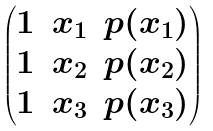Convert formula to latex. <formula><loc_0><loc_0><loc_500><loc_500>\begin{pmatrix} 1 & x _ { 1 } & p ( x _ { 1 } ) \\ 1 & x _ { 2 } & p ( x _ { 2 } ) \\ 1 & x _ { 3 } & p ( x _ { 3 } ) \end{pmatrix}</formula> 